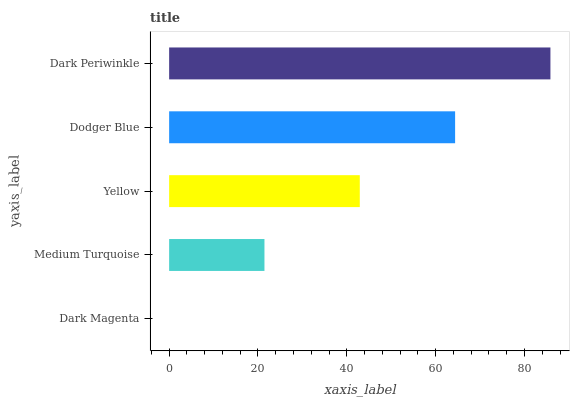Is Dark Magenta the minimum?
Answer yes or no. Yes. Is Dark Periwinkle the maximum?
Answer yes or no. Yes. Is Medium Turquoise the minimum?
Answer yes or no. No. Is Medium Turquoise the maximum?
Answer yes or no. No. Is Medium Turquoise greater than Dark Magenta?
Answer yes or no. Yes. Is Dark Magenta less than Medium Turquoise?
Answer yes or no. Yes. Is Dark Magenta greater than Medium Turquoise?
Answer yes or no. No. Is Medium Turquoise less than Dark Magenta?
Answer yes or no. No. Is Yellow the high median?
Answer yes or no. Yes. Is Yellow the low median?
Answer yes or no. Yes. Is Dark Magenta the high median?
Answer yes or no. No. Is Medium Turquoise the low median?
Answer yes or no. No. 